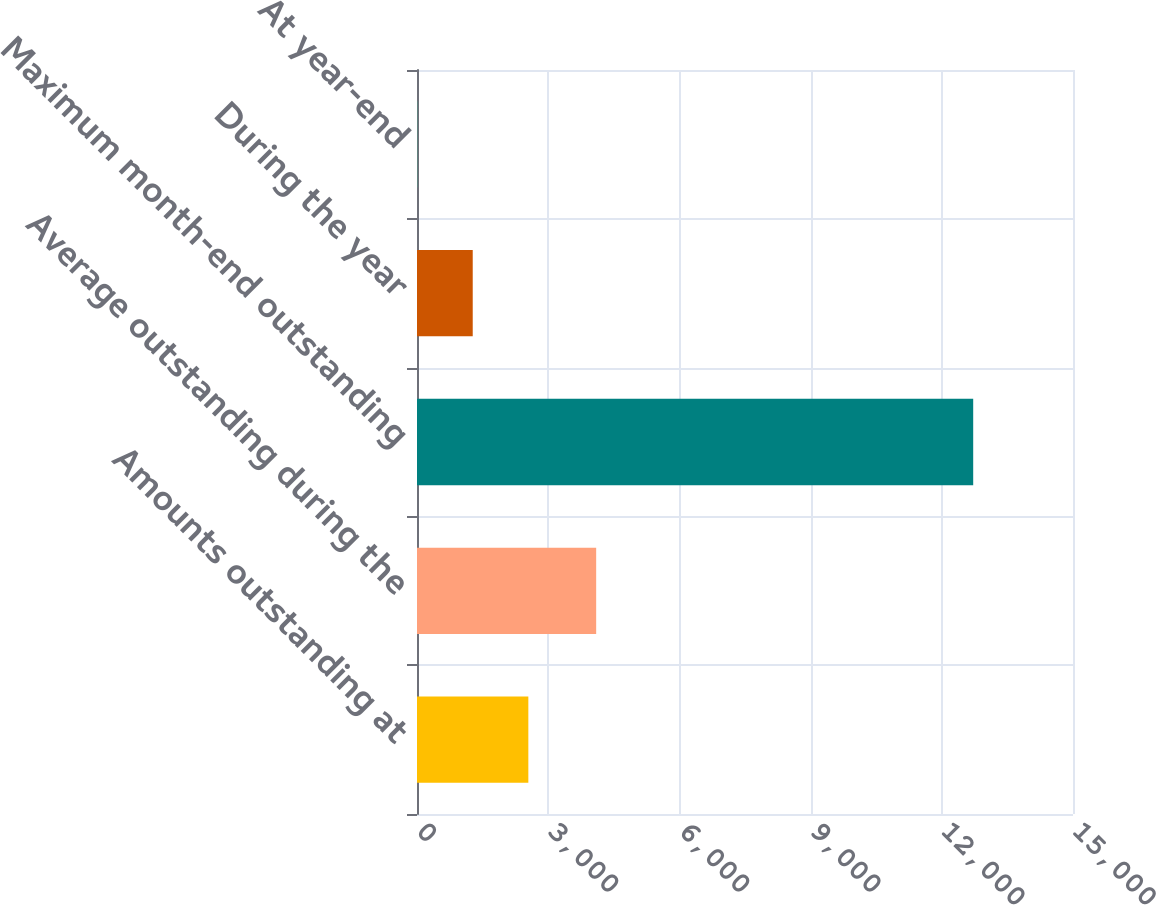Convert chart to OTSL. <chart><loc_0><loc_0><loc_500><loc_500><bar_chart><fcel>Amounts outstanding at<fcel>Average outstanding during the<fcel>Maximum month-end outstanding<fcel>During the year<fcel>At year-end<nl><fcel>2545.83<fcel>4097<fcel>12718<fcel>1274.31<fcel>2.79<nl></chart> 